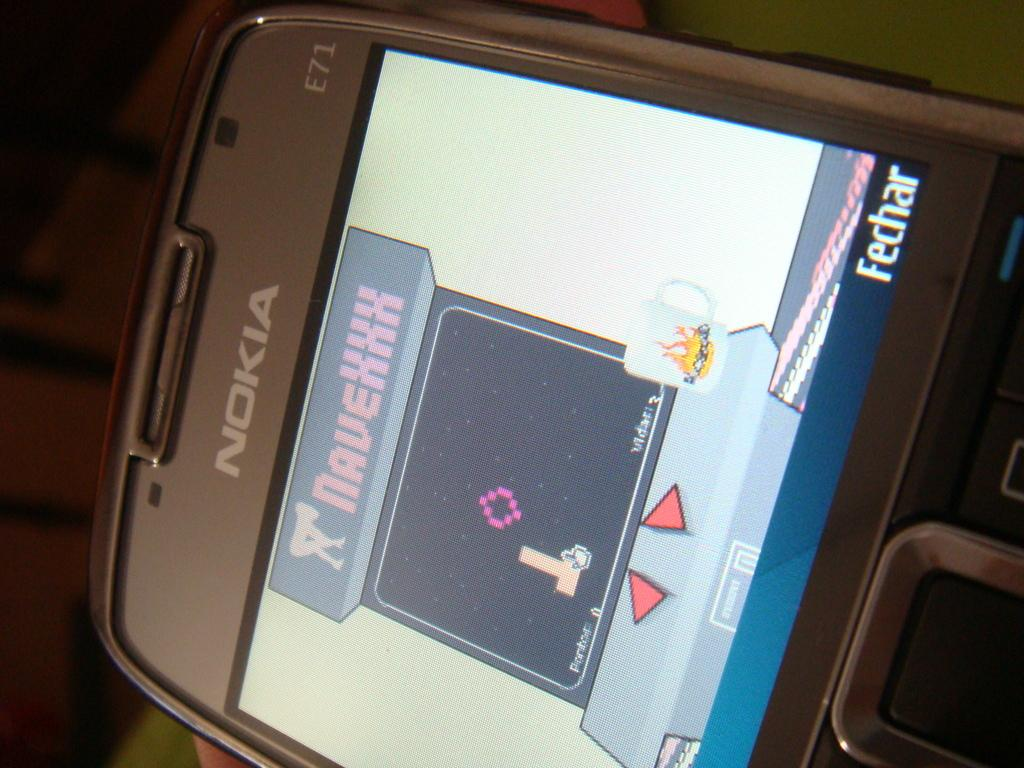<image>
Provide a brief description of the given image. A nokia device with a game of some sort on the screen. 